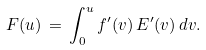<formula> <loc_0><loc_0><loc_500><loc_500>F ( u ) \, = \, \int _ { 0 } ^ { u } f ^ { \prime } ( v ) \, E ^ { \prime } ( v ) \, d v .</formula> 